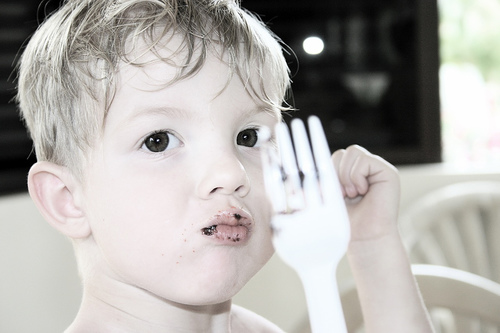<image>
Is there a fork next to the child? Yes. The fork is positioned adjacent to the child, located nearby in the same general area. Is the icing in the lip? Yes. The icing is contained within or inside the lip, showing a containment relationship. Is the plastic fork in front of the boy? Yes. The plastic fork is positioned in front of the boy, appearing closer to the camera viewpoint. 